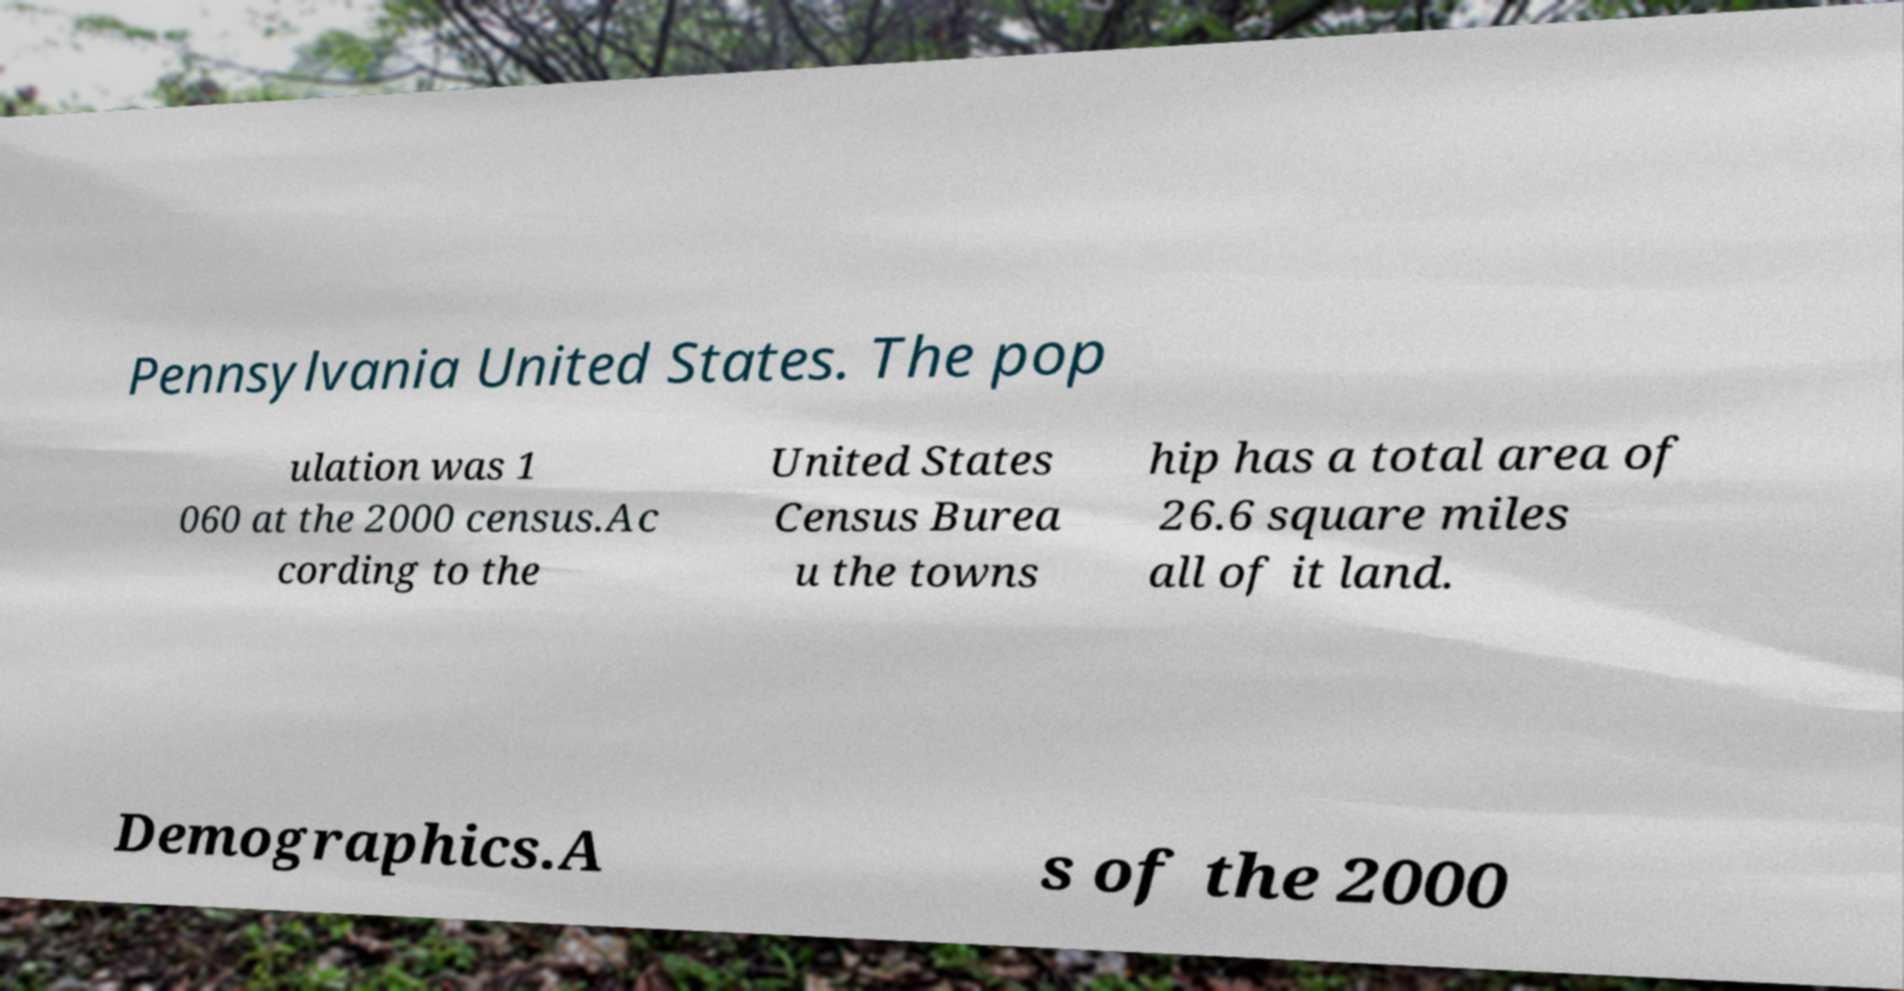Please identify and transcribe the text found in this image. Pennsylvania United States. The pop ulation was 1 060 at the 2000 census.Ac cording to the United States Census Burea u the towns hip has a total area of 26.6 square miles all of it land. Demographics.A s of the 2000 